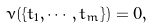Convert formula to latex. <formula><loc_0><loc_0><loc_500><loc_500>\nu ( \{ t _ { 1 } , \cdots , t _ { m } \} ) = 0 ,</formula> 